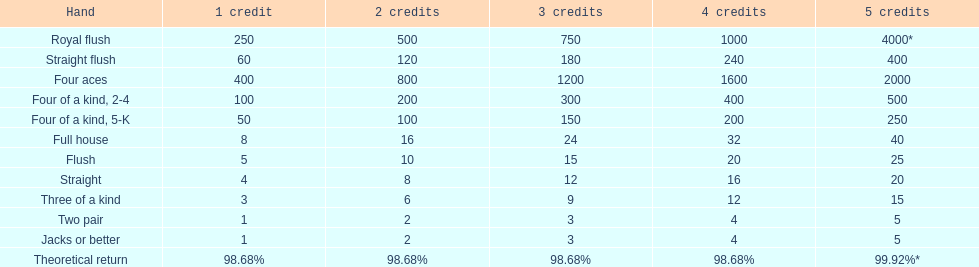What is the amount of credits received for a one credit wager on a royal flush? 250. 